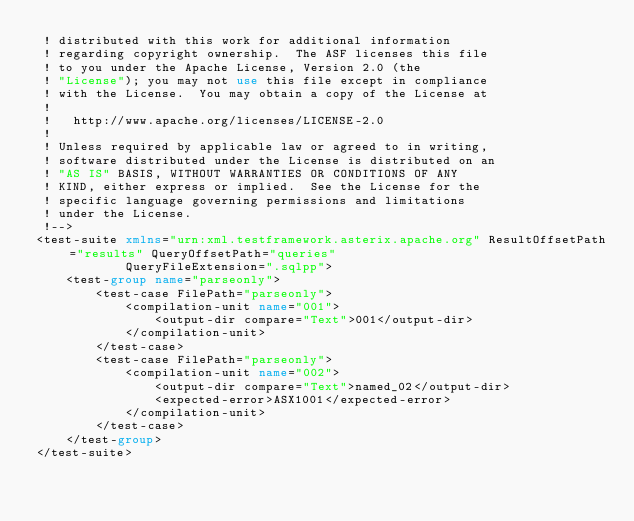Convert code to text. <code><loc_0><loc_0><loc_500><loc_500><_XML_> ! distributed with this work for additional information
 ! regarding copyright ownership.  The ASF licenses this file
 ! to you under the Apache License, Version 2.0 (the
 ! "License"); you may not use this file except in compliance
 ! with the License.  You may obtain a copy of the License at
 !
 !   http://www.apache.org/licenses/LICENSE-2.0
 !
 ! Unless required by applicable law or agreed to in writing,
 ! software distributed under the License is distributed on an
 ! "AS IS" BASIS, WITHOUT WARRANTIES OR CONDITIONS OF ANY
 ! KIND, either express or implied.  See the License for the
 ! specific language governing permissions and limitations
 ! under the License.
 !-->
<test-suite xmlns="urn:xml.testframework.asterix.apache.org" ResultOffsetPath="results" QueryOffsetPath="queries"
            QueryFileExtension=".sqlpp">
    <test-group name="parseonly">
        <test-case FilePath="parseonly">
            <compilation-unit name="001">
                <output-dir compare="Text">001</output-dir>
            </compilation-unit>
        </test-case>
        <test-case FilePath="parseonly">
            <compilation-unit name="002">
                <output-dir compare="Text">named_02</output-dir>
                <expected-error>ASX1001</expected-error>
            </compilation-unit>
        </test-case>
    </test-group>
</test-suite>
</code> 